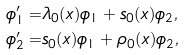Convert formula to latex. <formula><loc_0><loc_0><loc_500><loc_500>\phi _ { 1 } ^ { \prime } = & \lambda _ { 0 } ( x ) \phi _ { 1 } + s _ { 0 } ( x ) \phi _ { 2 } , \\ \phi _ { 2 } ^ { \prime } = & s _ { 0 } ( x ) \phi _ { 1 } + \rho _ { 0 } ( x ) \phi _ { 2 } ,</formula> 